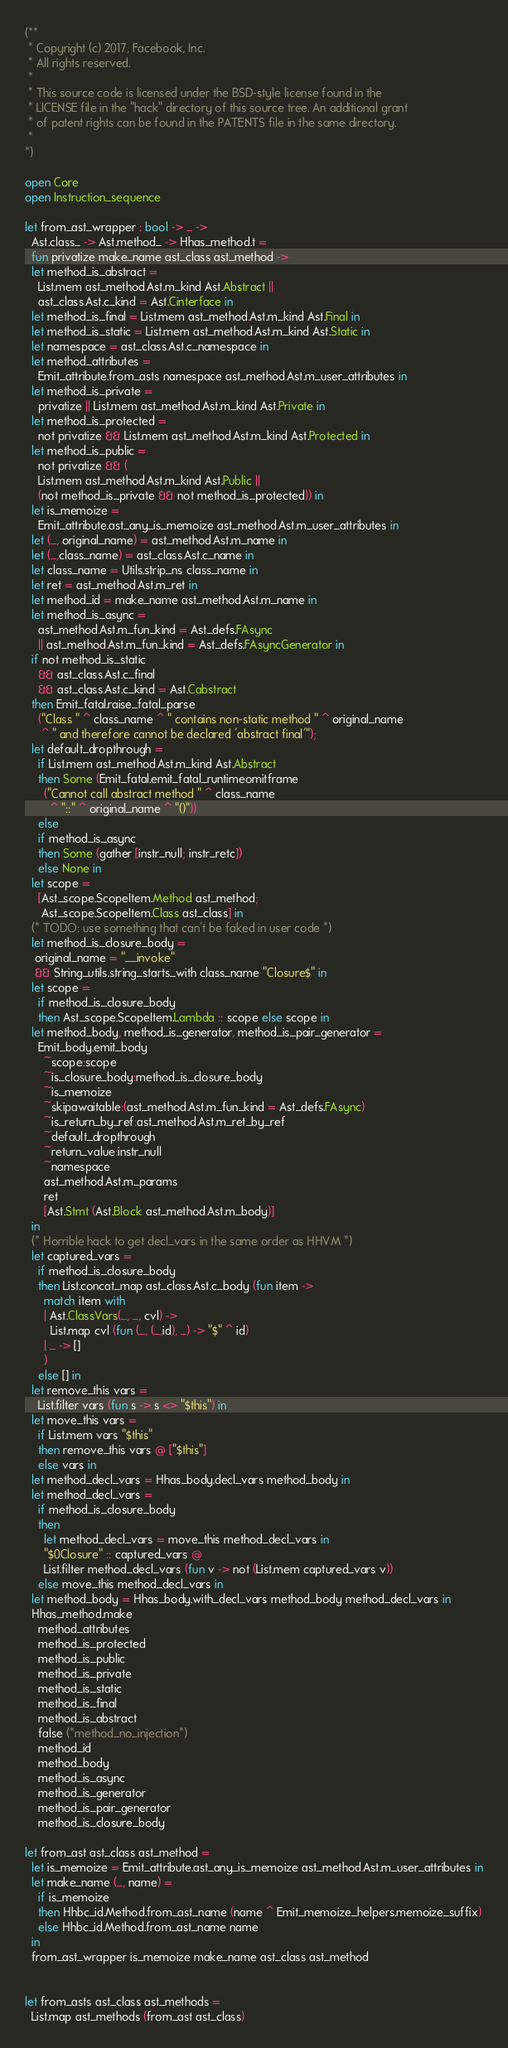<code> <loc_0><loc_0><loc_500><loc_500><_OCaml_>(**
 * Copyright (c) 2017, Facebook, Inc.
 * All rights reserved.
 *
 * This source code is licensed under the BSD-style license found in the
 * LICENSE file in the "hack" directory of this source tree. An additional grant
 * of patent rights can be found in the PATENTS file in the same directory.
 *
*)

open Core
open Instruction_sequence

let from_ast_wrapper : bool -> _ ->
  Ast.class_ -> Ast.method_ -> Hhas_method.t =
  fun privatize make_name ast_class ast_method ->
  let method_is_abstract =
    List.mem ast_method.Ast.m_kind Ast.Abstract ||
    ast_class.Ast.c_kind = Ast.Cinterface in
  let method_is_final = List.mem ast_method.Ast.m_kind Ast.Final in
  let method_is_static = List.mem ast_method.Ast.m_kind Ast.Static in
  let namespace = ast_class.Ast.c_namespace in
  let method_attributes =
    Emit_attribute.from_asts namespace ast_method.Ast.m_user_attributes in
  let method_is_private =
    privatize || List.mem ast_method.Ast.m_kind Ast.Private in
  let method_is_protected =
    not privatize && List.mem ast_method.Ast.m_kind Ast.Protected in
  let method_is_public =
    not privatize && (
    List.mem ast_method.Ast.m_kind Ast.Public ||
    (not method_is_private && not method_is_protected)) in
  let is_memoize =
    Emit_attribute.ast_any_is_memoize ast_method.Ast.m_user_attributes in
  let (_, original_name) = ast_method.Ast.m_name in
  let (_,class_name) = ast_class.Ast.c_name in
  let class_name = Utils.strip_ns class_name in
  let ret = ast_method.Ast.m_ret in
  let method_id = make_name ast_method.Ast.m_name in
  let method_is_async =
    ast_method.Ast.m_fun_kind = Ast_defs.FAsync
    || ast_method.Ast.m_fun_kind = Ast_defs.FAsyncGenerator in
  if not method_is_static
    && ast_class.Ast.c_final
    && ast_class.Ast.c_kind = Ast.Cabstract
  then Emit_fatal.raise_fatal_parse
    ("Class " ^ class_name ^ " contains non-static method " ^ original_name
     ^ " and therefore cannot be declared 'abstract final'");
  let default_dropthrough =
    if List.mem ast_method.Ast.m_kind Ast.Abstract
    then Some (Emit_fatal.emit_fatal_runtimeomitframe
      ("Cannot call abstract method " ^ class_name
        ^ "::" ^ original_name ^ "()"))
    else
    if method_is_async
    then Some (gather [instr_null; instr_retc])
    else None in
  let scope =
    [Ast_scope.ScopeItem.Method ast_method;
     Ast_scope.ScopeItem.Class ast_class] in
  (* TODO: use something that can't be faked in user code *)
  let method_is_closure_body =
   original_name = "__invoke"
   && String_utils.string_starts_with class_name "Closure$" in
  let scope =
    if method_is_closure_body
    then Ast_scope.ScopeItem.Lambda :: scope else scope in
  let method_body, method_is_generator, method_is_pair_generator =
    Emit_body.emit_body
      ~scope:scope
      ~is_closure_body:method_is_closure_body
      ~is_memoize
      ~skipawaitable:(ast_method.Ast.m_fun_kind = Ast_defs.FAsync)
      ~is_return_by_ref:ast_method.Ast.m_ret_by_ref
      ~default_dropthrough
      ~return_value:instr_null
      ~namespace
      ast_method.Ast.m_params
      ret
      [Ast.Stmt (Ast.Block ast_method.Ast.m_body)]
  in
  (* Horrible hack to get decl_vars in the same order as HHVM *)
  let captured_vars =
    if method_is_closure_body
    then List.concat_map ast_class.Ast.c_body (fun item ->
      match item with
      | Ast.ClassVars(_, _, cvl) ->
        List.map cvl (fun (_, (_,id), _) -> "$" ^ id)
      | _ -> []
      )
    else [] in
  let remove_this vars =
    List.filter vars (fun s -> s <> "$this") in
  let move_this vars =
    if List.mem vars "$this"
    then remove_this vars @ ["$this"]
    else vars in
  let method_decl_vars = Hhas_body.decl_vars method_body in
  let method_decl_vars =
    if method_is_closure_body
    then
      let method_decl_vars = move_this method_decl_vars in
      "$0Closure" :: captured_vars @
      List.filter method_decl_vars (fun v -> not (List.mem captured_vars v))
    else move_this method_decl_vars in
  let method_body = Hhas_body.with_decl_vars method_body method_decl_vars in
  Hhas_method.make
    method_attributes
    method_is_protected
    method_is_public
    method_is_private
    method_is_static
    method_is_final
    method_is_abstract
    false (*method_no_injection*)
    method_id
    method_body
    method_is_async
    method_is_generator
    method_is_pair_generator
    method_is_closure_body

let from_ast ast_class ast_method =
  let is_memoize = Emit_attribute.ast_any_is_memoize ast_method.Ast.m_user_attributes in
  let make_name (_, name) =
    if is_memoize
    then Hhbc_id.Method.from_ast_name (name ^ Emit_memoize_helpers.memoize_suffix)
    else Hhbc_id.Method.from_ast_name name
  in
  from_ast_wrapper is_memoize make_name ast_class ast_method


let from_asts ast_class ast_methods =
  List.map ast_methods (from_ast ast_class)
</code> 